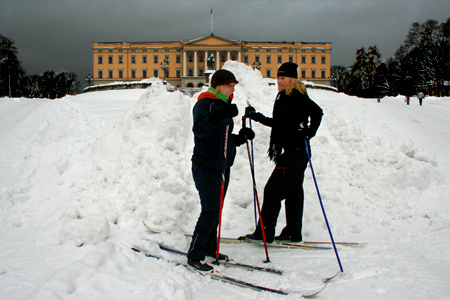Do both these people have the sharegpt4v/same gender? Yes, both individuals appear to be of the sharegpt4v/same gender. 